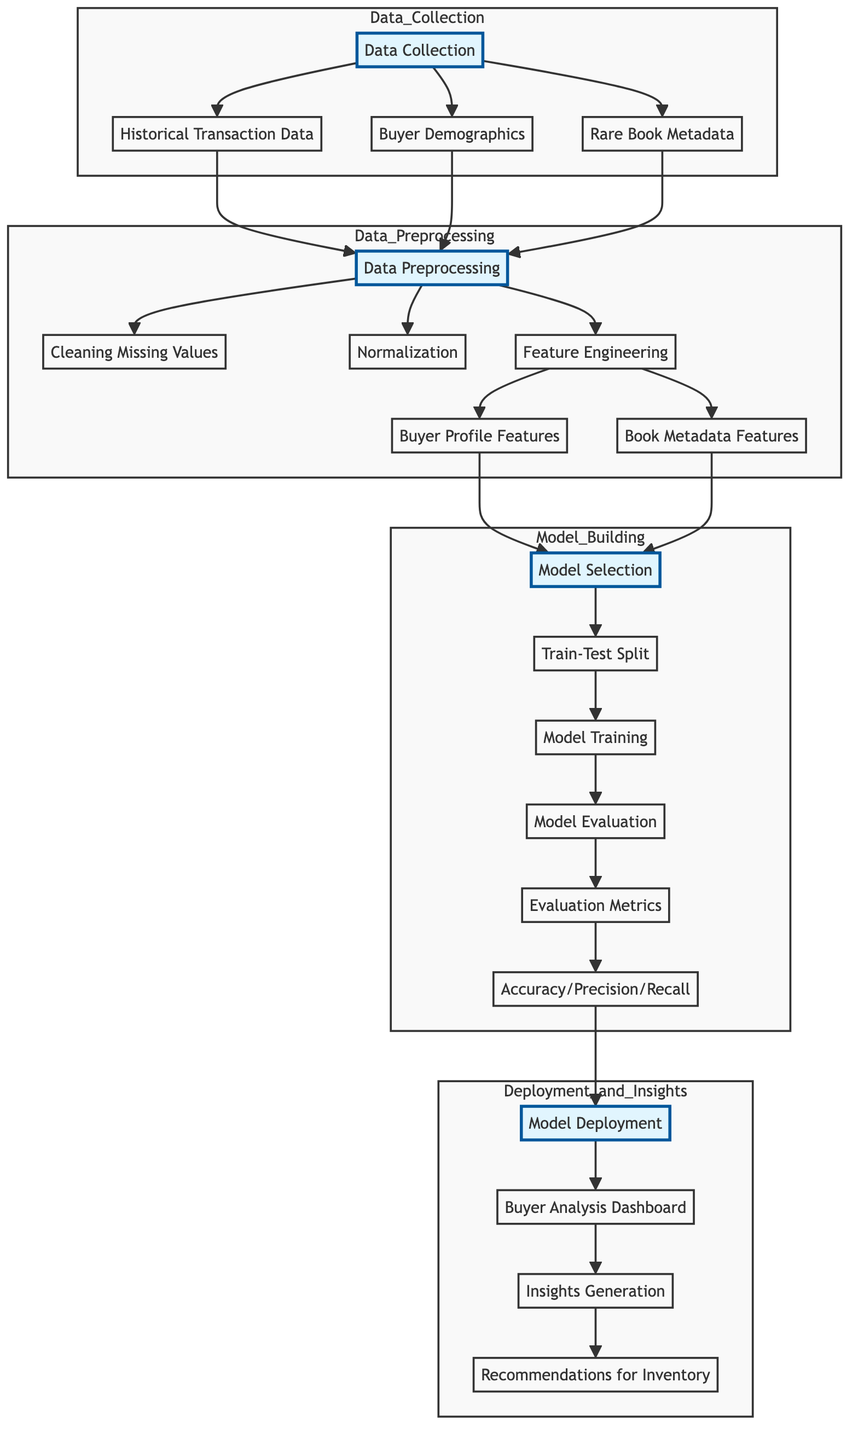What are the three main components in the Data Collection subgraph? The Data Collection subgraph consists of three main components: Historical Transaction Data, Buyer Demographics, and Rare Book Metadata.
Answer: Historical Transaction Data, Buyer Demographics, Rare Book Metadata How many nodes are in the Model Building subgraph? The Model Building subgraph contains five nodes: Model Selection, Train-Test Split, Model Training, Model Evaluation, and Evaluation Metrics.
Answer: Five What is the relationship between Data Preprocessing and Feature Engineering? Data Preprocessing leads to Feature Engineering, as it is a step where specific features for Buyer Profiles and Book Metadata are created from the preprocessed data.
Answer: Leads to Which component generates insights and recommendations after model deployment? The Insights Generation component generates insights and recommendations after model deployment.
Answer: Insights Generation In what sequence does Model Evaluation occur after either Model Training or Evaluation Metrics? Model Evaluation occurs after Model Training and before Evaluation Metrics, indicating a step-by-step progression in the process.
Answer: After Model Training What is the first step in the Data Collection subgraph? The first step in the Data Collection subgraph is Data Collection itself.
Answer: Data Collection What type of analysis is represented in the Deployment and Insights subgraph? The type of analysis represented is Buyer Analysis.
Answer: Buyer Analysis What are the final outcomes of the entire flow depicted in the diagram? The final outcomes are Recommendations for Inventory, which follows after the insights are generated from Buyer Analysis.
Answer: Recommendations for Inventory 